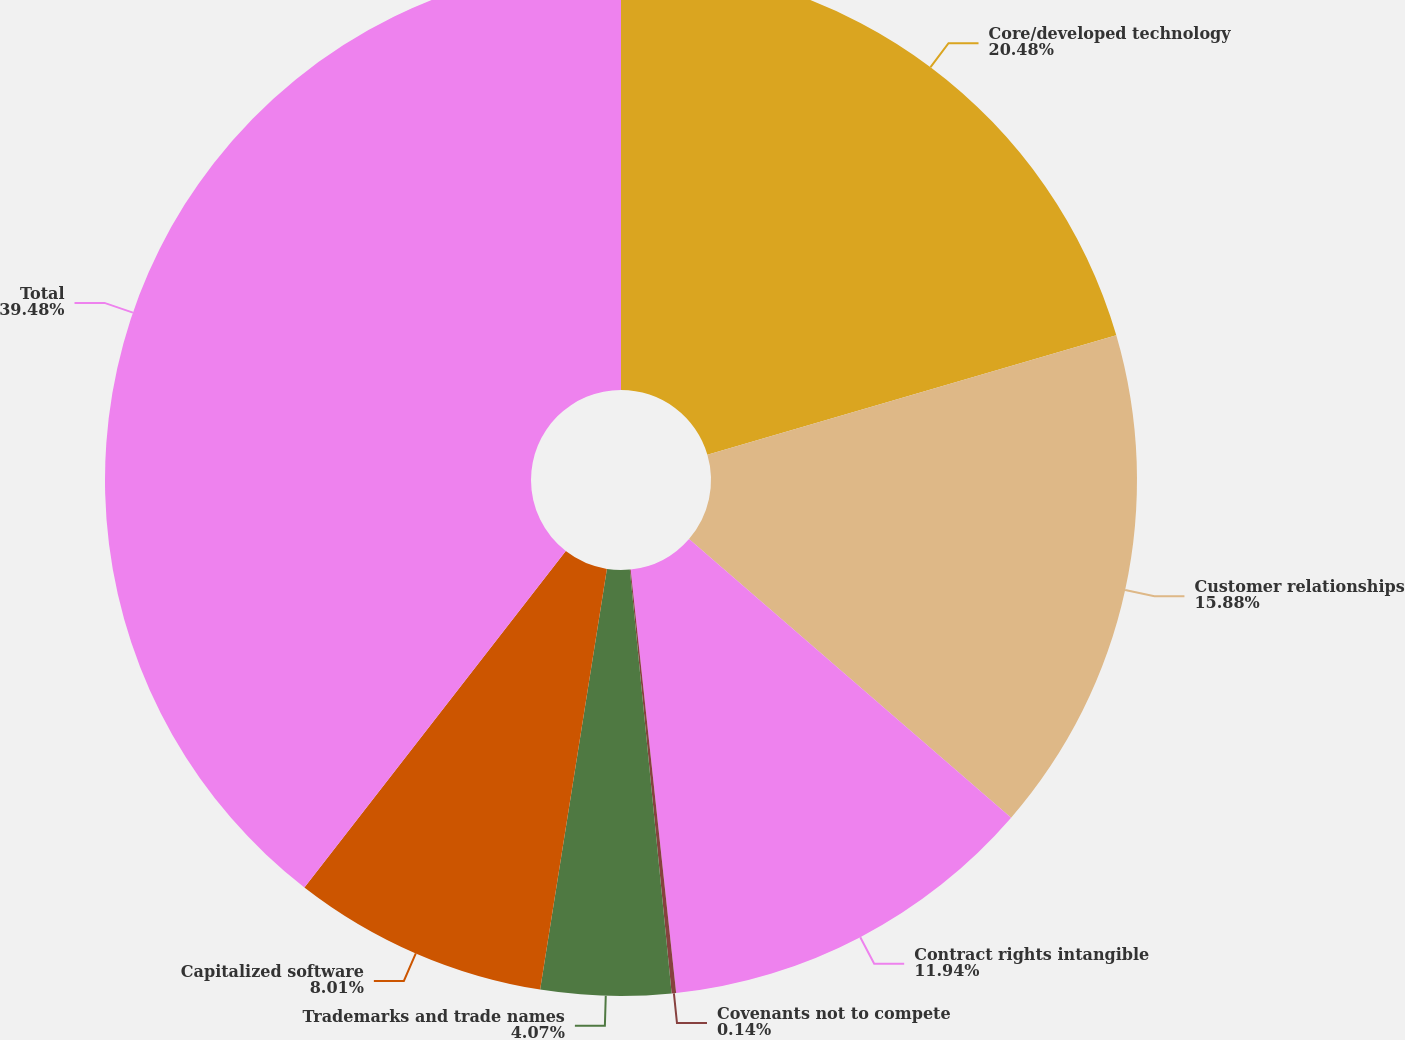<chart> <loc_0><loc_0><loc_500><loc_500><pie_chart><fcel>Core/developed technology<fcel>Customer relationships<fcel>Contract rights intangible<fcel>Covenants not to compete<fcel>Trademarks and trade names<fcel>Capitalized software<fcel>Total<nl><fcel>20.48%<fcel>15.88%<fcel>11.94%<fcel>0.14%<fcel>4.07%<fcel>8.01%<fcel>39.49%<nl></chart> 